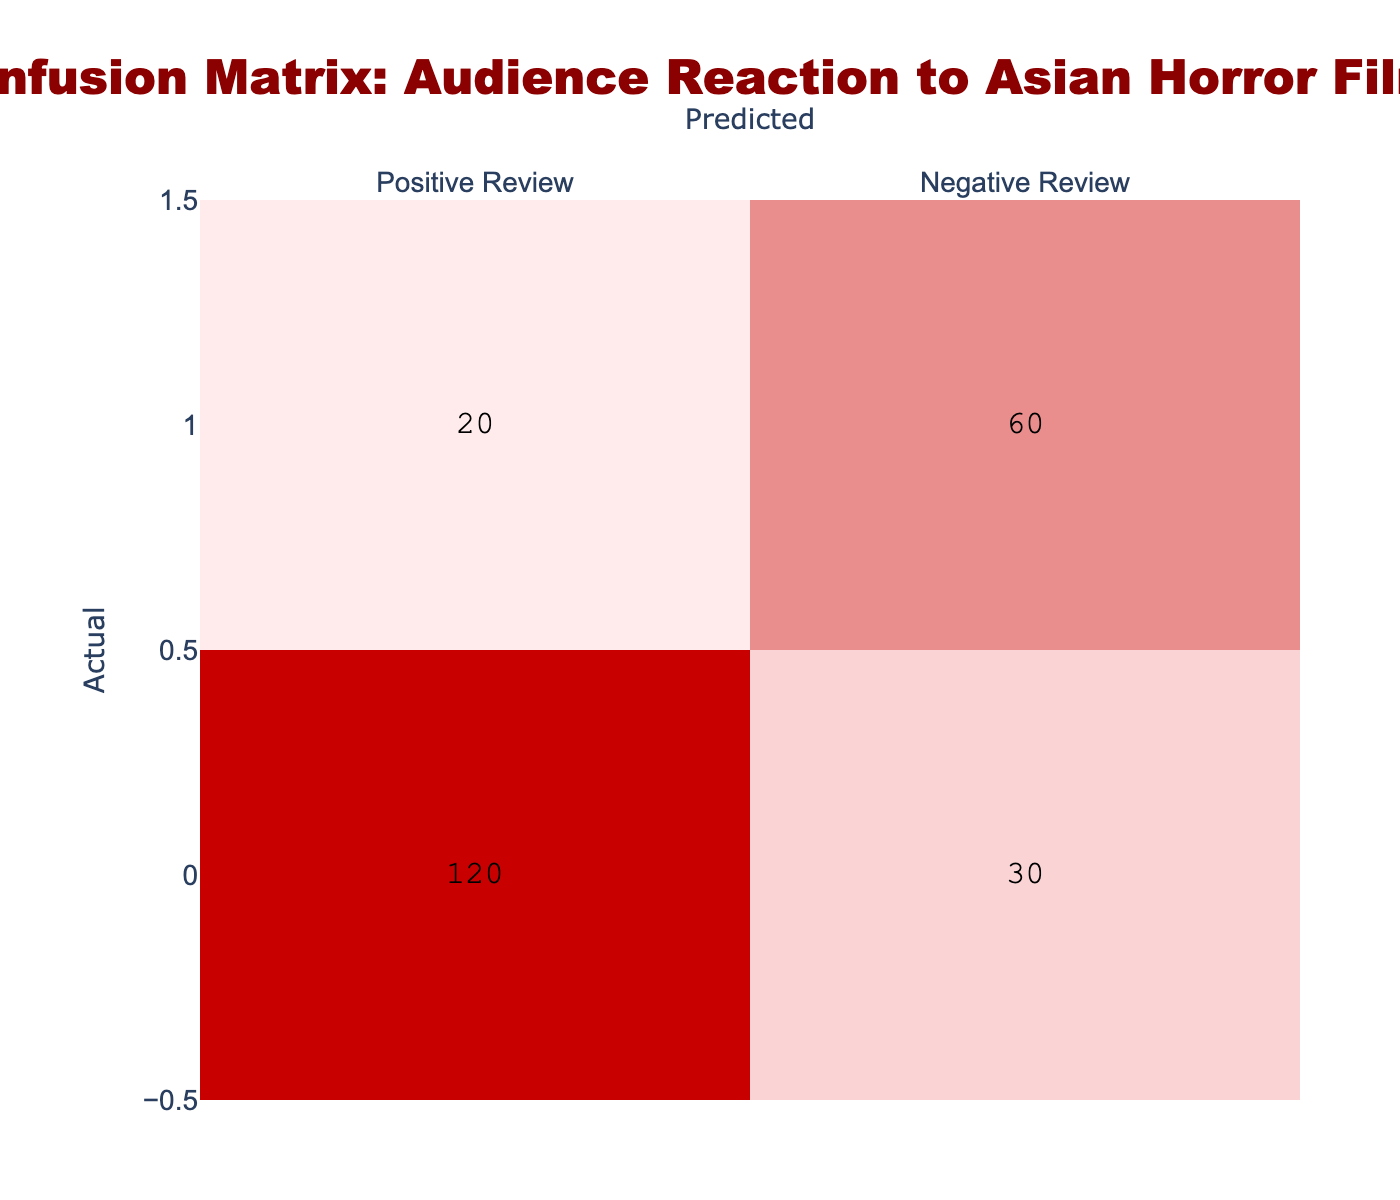What is the total number of Positive Reviews? To find the total number of Positive Reviews, we look at the 'Positive Review' row in the Actual column. We sum the values in that row: 120 (True Positives) + 30 (False Negatives) = 150.
Answer: 150 What is the total number of Negative Reviews? To determine the total number of Negative Reviews, we refer to the 'Negative Review' row in the Actual column. We sum the values in that row: 20 (False Positives) + 60 (True Negatives) = 80.
Answer: 80 How many films received a Negative Review but were predicted as Positive? We look at the False Negatives in the table, which are the films that received a Negative Review but were predicted as Positive. The value indicated in the 'Positive Review' under actual Negative Review is 20.
Answer: 20 What is the accuracy of the predictions made regarding the reviews? Accuracy is calculated using the formula: (True Positives + True Negatives) / Total Predictions. Here, it is (120 + 60) / (120 + 30 + 20 + 60) = 180 / 230 = 0.7826, or 78.26%.
Answer: 78.26% Were more films accurately predicted as having Positive Reviews than Negative Reviews? To find this, we compare True Positives (120) and True Negatives (60). Since 120 > 60, more films were accurately predicted as having Positive Reviews.
Answer: Yes What is the total number of films that were predicted to have Positive Reviews? We sum all the values in the 'Positive Review' column: 120 (True Positives) + 20 (False Positives) = 140.
Answer: 140 How many films were misclassified as Positive Reviews? Misclassified films as Positive Reviews are summed from False Positives (20) and False Negatives (30). Thus, the total misclassified is 20 + 30 = 50.
Answer: 50 What percentage of films were accurately reviewed positively out of those predicted as positive? The percentage of accurately reviewed films can be calculated as (True Positives / Predicted Positives) x 100. Thus, it is (120 / 140) x 100 = 85.71%.
Answer: 85.71% If the films that received Negative Reviews were predicted positively, what is the combined total of mispredicted films? Mispredicted films are given by False Positives + False Negatives. Thus, it is 20 (False Positives) + 30 (False Negatives) = 50.
Answer: 50 